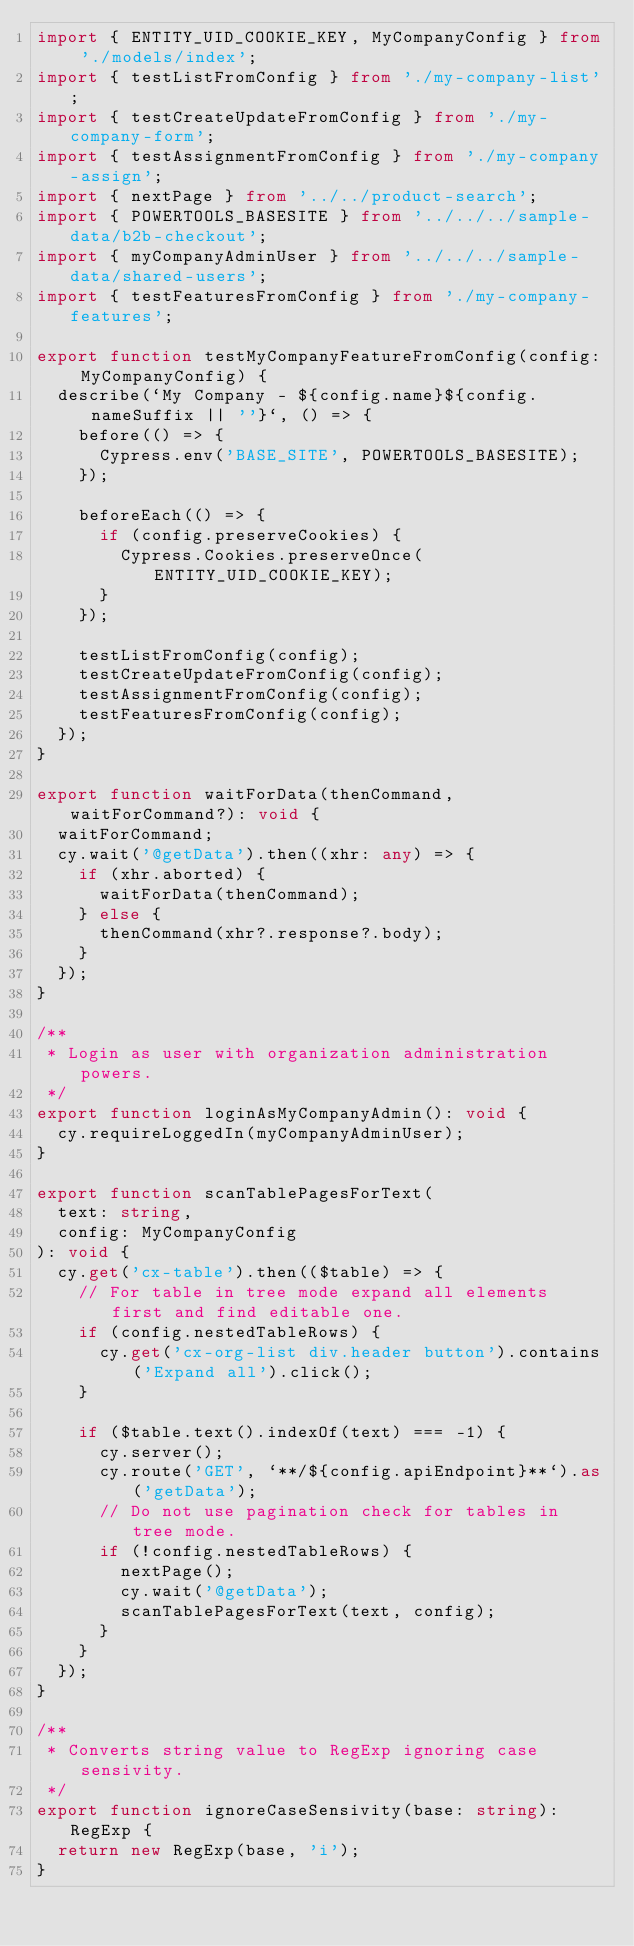Convert code to text. <code><loc_0><loc_0><loc_500><loc_500><_TypeScript_>import { ENTITY_UID_COOKIE_KEY, MyCompanyConfig } from './models/index';
import { testListFromConfig } from './my-company-list';
import { testCreateUpdateFromConfig } from './my-company-form';
import { testAssignmentFromConfig } from './my-company-assign';
import { nextPage } from '../../product-search';
import { POWERTOOLS_BASESITE } from '../../../sample-data/b2b-checkout';
import { myCompanyAdminUser } from '../../../sample-data/shared-users';
import { testFeaturesFromConfig } from './my-company-features';

export function testMyCompanyFeatureFromConfig(config: MyCompanyConfig) {
  describe(`My Company - ${config.name}${config.nameSuffix || ''}`, () => {
    before(() => {
      Cypress.env('BASE_SITE', POWERTOOLS_BASESITE);
    });

    beforeEach(() => {
      if (config.preserveCookies) {
        Cypress.Cookies.preserveOnce(ENTITY_UID_COOKIE_KEY);
      }
    });

    testListFromConfig(config);
    testCreateUpdateFromConfig(config);
    testAssignmentFromConfig(config);
    testFeaturesFromConfig(config);
  });
}

export function waitForData(thenCommand, waitForCommand?): void {
  waitForCommand;
  cy.wait('@getData').then((xhr: any) => {
    if (xhr.aborted) {
      waitForData(thenCommand);
    } else {
      thenCommand(xhr?.response?.body);
    }
  });
}

/**
 * Login as user with organization administration powers.
 */
export function loginAsMyCompanyAdmin(): void {
  cy.requireLoggedIn(myCompanyAdminUser);
}

export function scanTablePagesForText(
  text: string,
  config: MyCompanyConfig
): void {
  cy.get('cx-table').then(($table) => {
    // For table in tree mode expand all elements first and find editable one.
    if (config.nestedTableRows) {
      cy.get('cx-org-list div.header button').contains('Expand all').click();
    }

    if ($table.text().indexOf(text) === -1) {
      cy.server();
      cy.route('GET', `**/${config.apiEndpoint}**`).as('getData');
      // Do not use pagination check for tables in tree mode.
      if (!config.nestedTableRows) {
        nextPage();
        cy.wait('@getData');
        scanTablePagesForText(text, config);
      }
    }
  });
}

/**
 * Converts string value to RegExp ignoring case sensivity.
 */
export function ignoreCaseSensivity(base: string): RegExp {
  return new RegExp(base, 'i');
}
</code> 